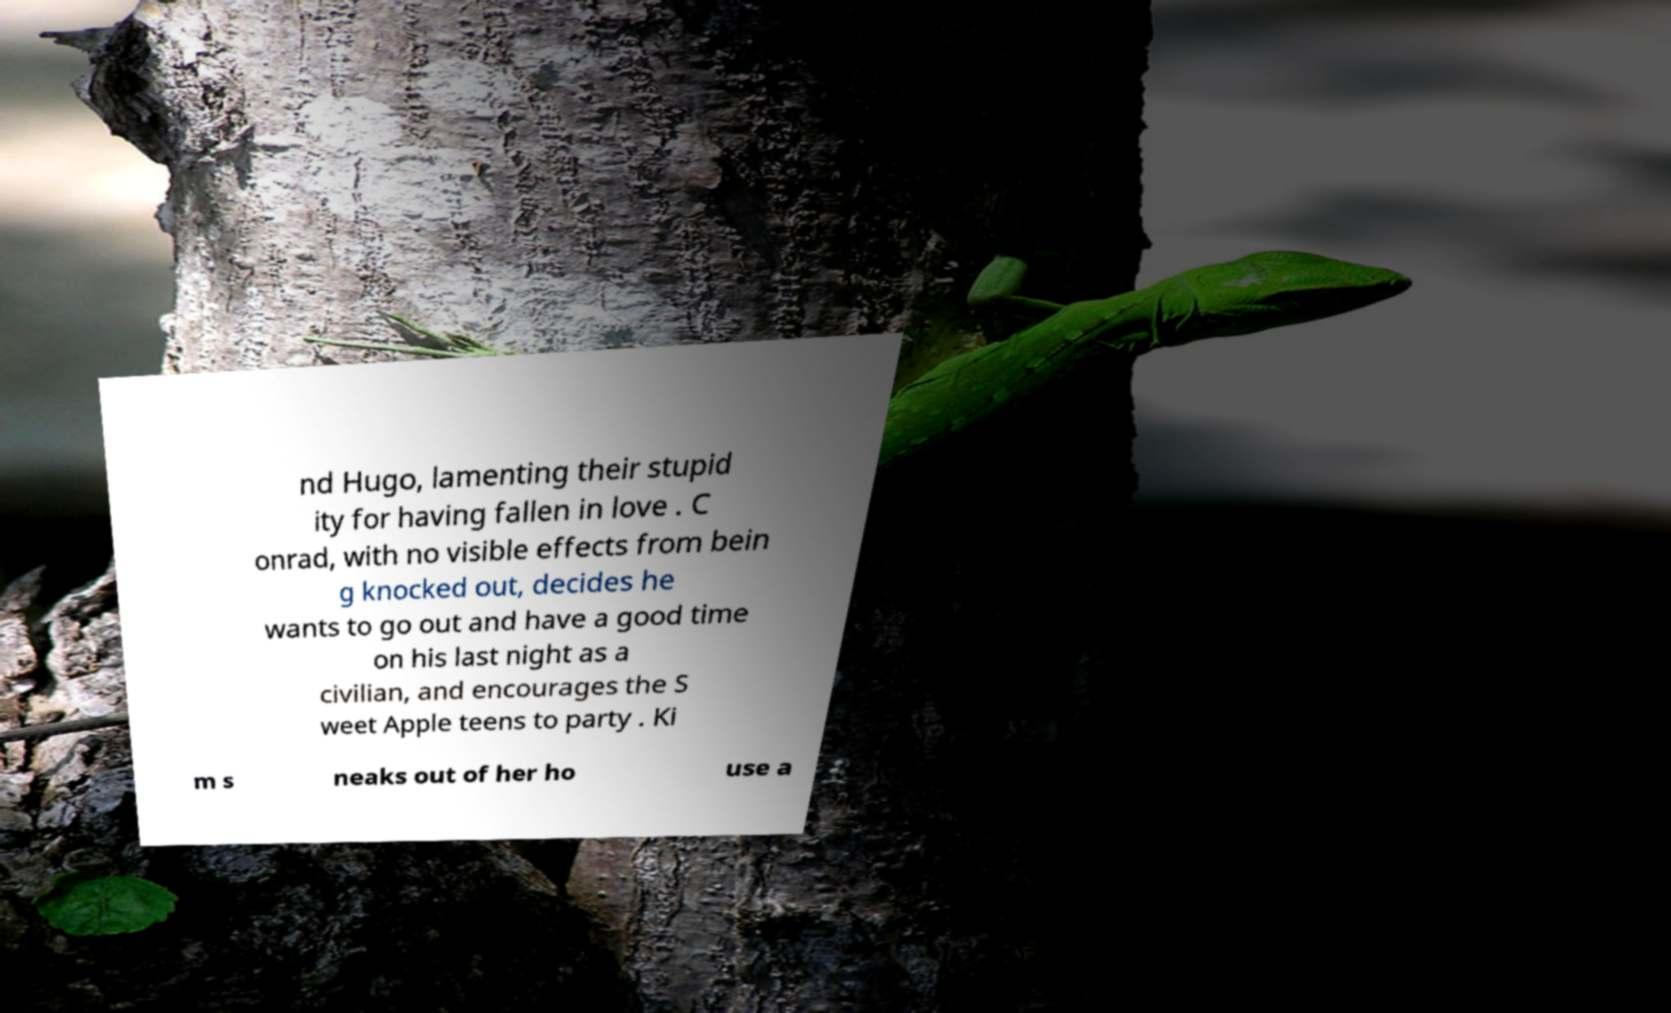There's text embedded in this image that I need extracted. Can you transcribe it verbatim? nd Hugo, lamenting their stupid ity for having fallen in love . C onrad, with no visible effects from bein g knocked out, decides he wants to go out and have a good time on his last night as a civilian, and encourages the S weet Apple teens to party . Ki m s neaks out of her ho use a 